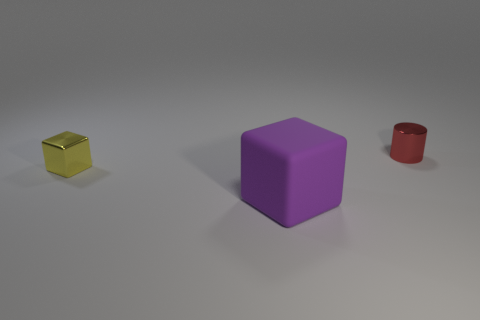Are there any other things that have the same material as the yellow thing?
Offer a very short reply. Yes. Do the purple thing and the tiny object that is in front of the tiny red cylinder have the same shape?
Make the answer very short. Yes. What number of things are in front of the small red object and behind the purple cube?
Provide a succinct answer. 1. Do the yellow block and the tiny object that is on the right side of the yellow thing have the same material?
Keep it short and to the point. Yes. Are there an equal number of tiny cubes that are right of the small red cylinder and tiny blocks?
Your answer should be compact. No. What is the color of the metallic thing that is on the right side of the small block?
Offer a very short reply. Red. Are there any other things that are the same size as the purple matte thing?
Make the answer very short. No. There is a metallic object that is left of the cylinder; is it the same size as the large rubber block?
Provide a short and direct response. No. There is a small object that is on the right side of the purple cube; what is its material?
Provide a short and direct response. Metal. Is there anything else that has the same shape as the big rubber object?
Keep it short and to the point. Yes. 